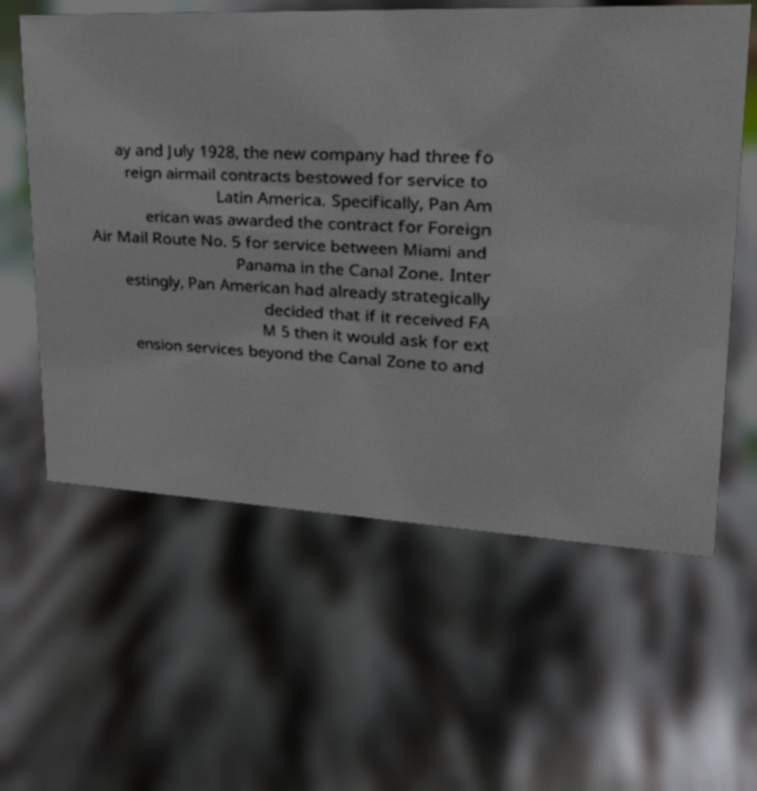There's text embedded in this image that I need extracted. Can you transcribe it verbatim? ay and July 1928, the new company had three fo reign airmail contracts bestowed for service to Latin America. Specifically, Pan Am erican was awarded the contract for Foreign Air Mail Route No. 5 for service between Miami and Panama in the Canal Zone. Inter estingly, Pan American had already strategically decided that if it received FA M 5 then it would ask for ext ension services beyond the Canal Zone to and 